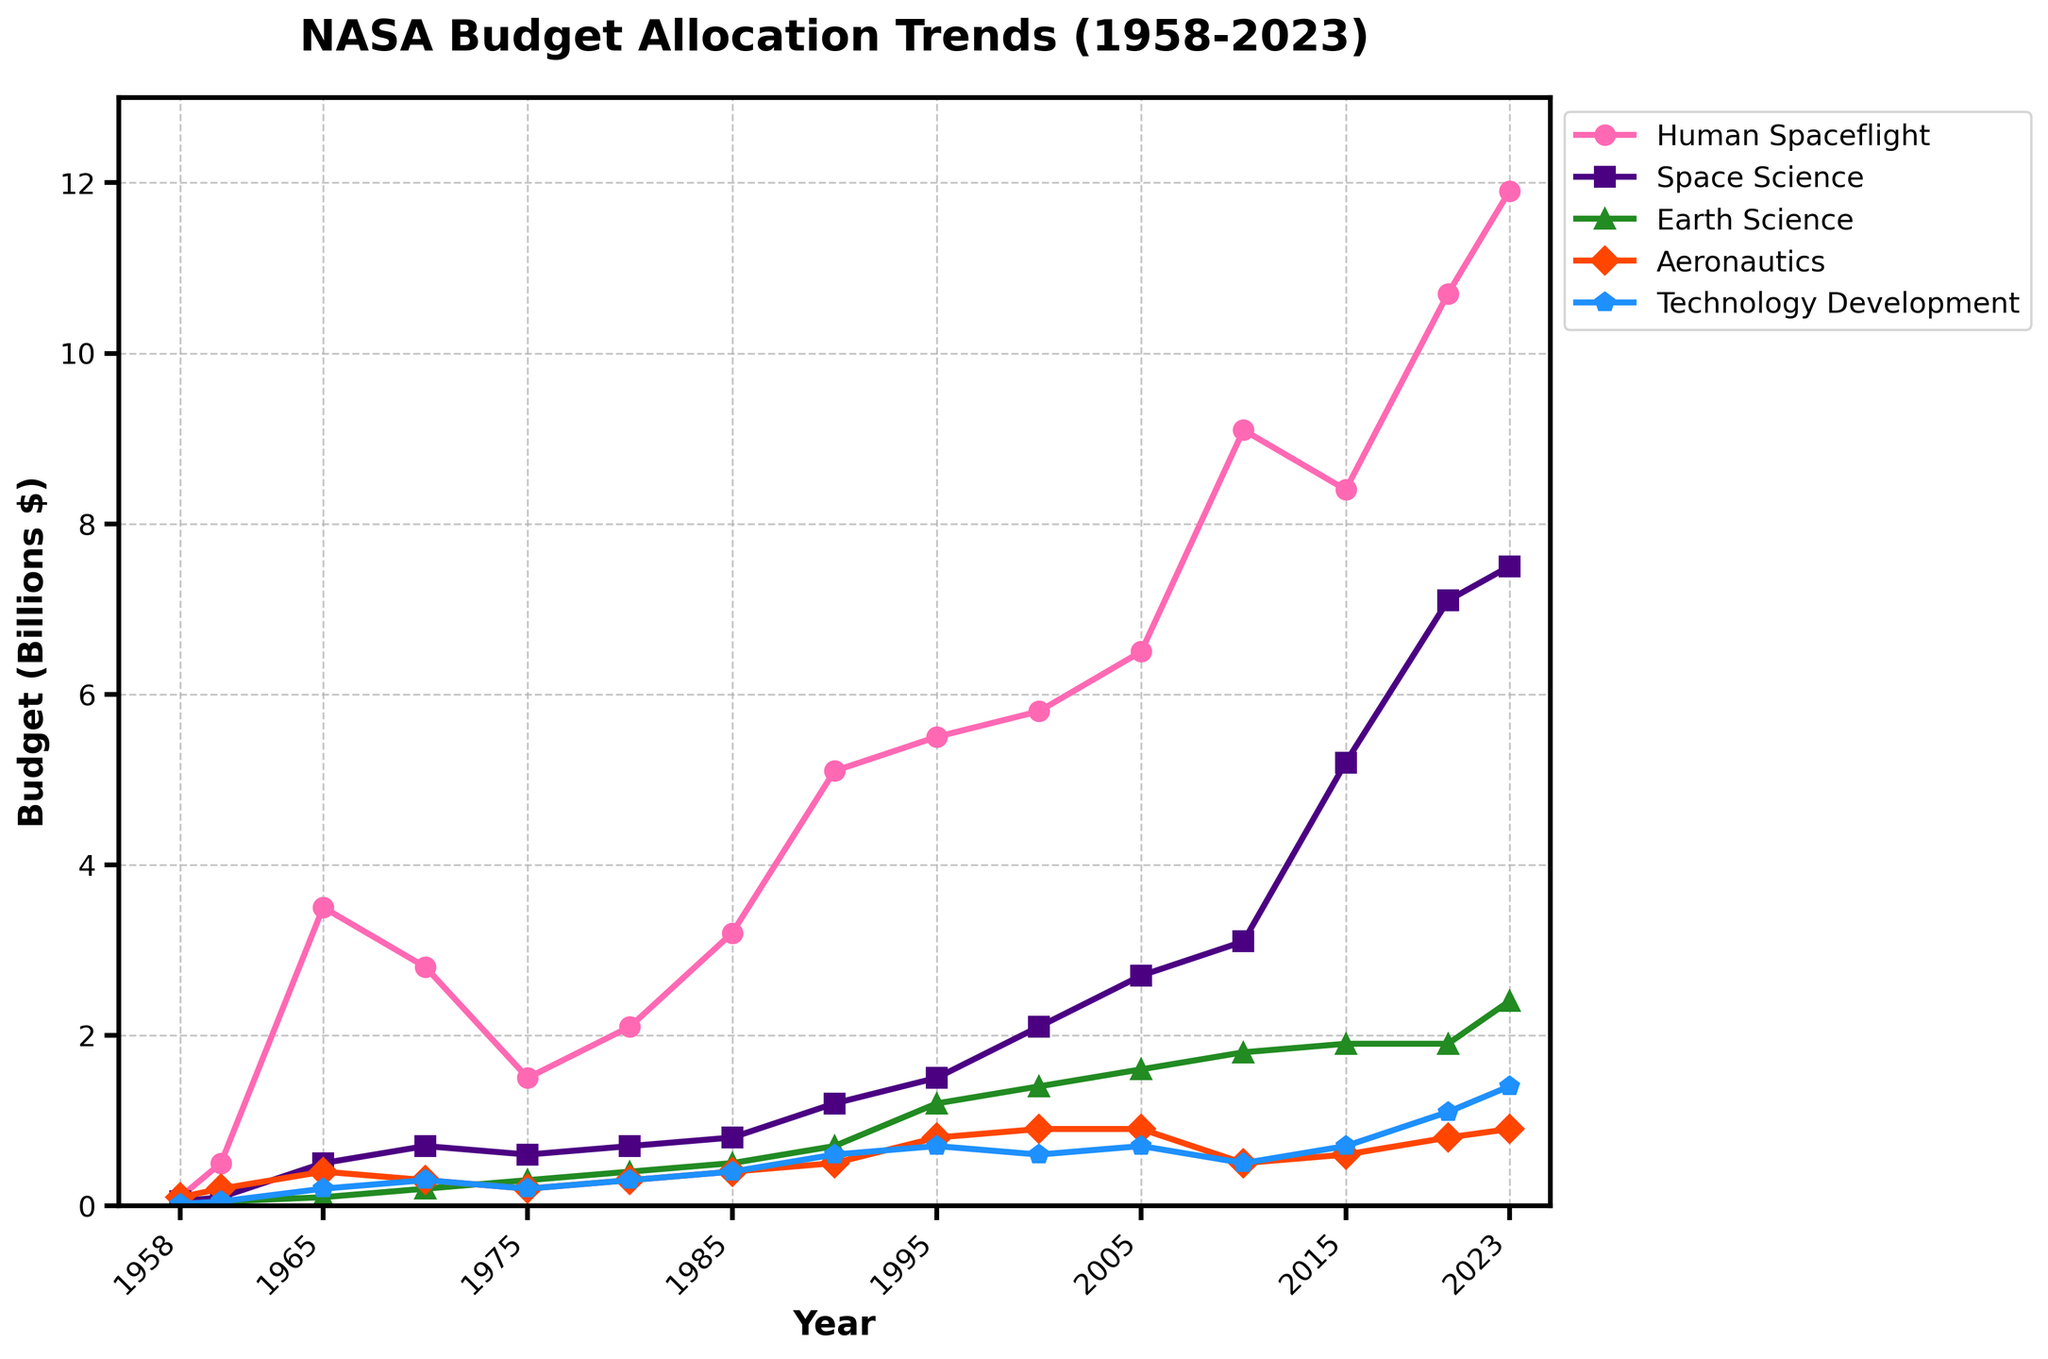What program area saw the greatest growth from 1958 to 2023? First, determine the budget allocation for each program area in 1958 and 2023. Then, calculate the difference from 1958 to 2023 for each area. Human spaceflight grew from 0.1 to 11.9 billion dollars, which is the largest increase.
Answer: Human Spaceflight How did the allocation for Aeronautics change between 1970 and 2010? Identify the budget for Aeronautics in 1970 (0.3 billion dollars) and in 2010 (0.5 billion dollars), then calculate the difference: 0.5 - 0.3 = 0.2 billion dollars.
Answer: Increased by 0.2 billion dollars Which two program areas have the closest budget allocation in 2023? Find the budget allocation for all program areas in 2023, which are: Human Spaceflight (11.9), Space Science (7.5), Earth Science (2.4), Aeronautics (0.9), and Technology Development (1.4). Compare the differences and find the smallest difference, which is between Aeronautics (0.9) and Technology Development (1.4).
Answer: Aeronautics and Technology Development During which decade did Space Science experience the most significant increase in funding? Observe the Space Science budget from 1958 to 2023: the first notable increase is between 2010 (3.1) and 2015 (5.2). Calculate the increase: 5.2 - 3.1 = 2.1 billion dollars. This is the largest increase within a decade.
Answer: 2010-2020 Which program had a higher budget in 2023, Earth Science or Technology Development? Look at the budget in 2023: Earth Science is 2.4 billion dollars, and Technology Development is 1.4 billion dollars.
Answer: Earth Science What is the average budget allocation for Human Spaceflight from 2000 to 2023? Sum the Human Spaceflight values from 2000 (5.8), 2005 (6.5), 2010 (9.1), 2015 (8.4), 2020 (10.7), and 2023 (11.9), then divide by 6: (5.8 + 6.5 + 9.1 + 8.4 + 10.7 + 11.9) / 6 = 8.73 billion dollars.
Answer: 8.73 billion dollars In which year did Technology Development surpass 1 billion dollars for the first time? Track the Technology Development data and find the first year when it exceeds 1 billion, which is 2020 (1.1 billion dollars).
Answer: 2020 How do the budgets for Earth Science in 1990 and 2023 compare? Compare the 1990 Earth Science budget (0.7 billion dollars) with the 2023 budget (2.4 billion dollars).
Answer: 2023 is higher Which program area fluctuated the least in terms of budget allocation between 1958 and 2023? Analyze the relative stability of budget allocation in each program area. Aeronautics has the least fluctuation compared to others.
Answer: Aeronautics 